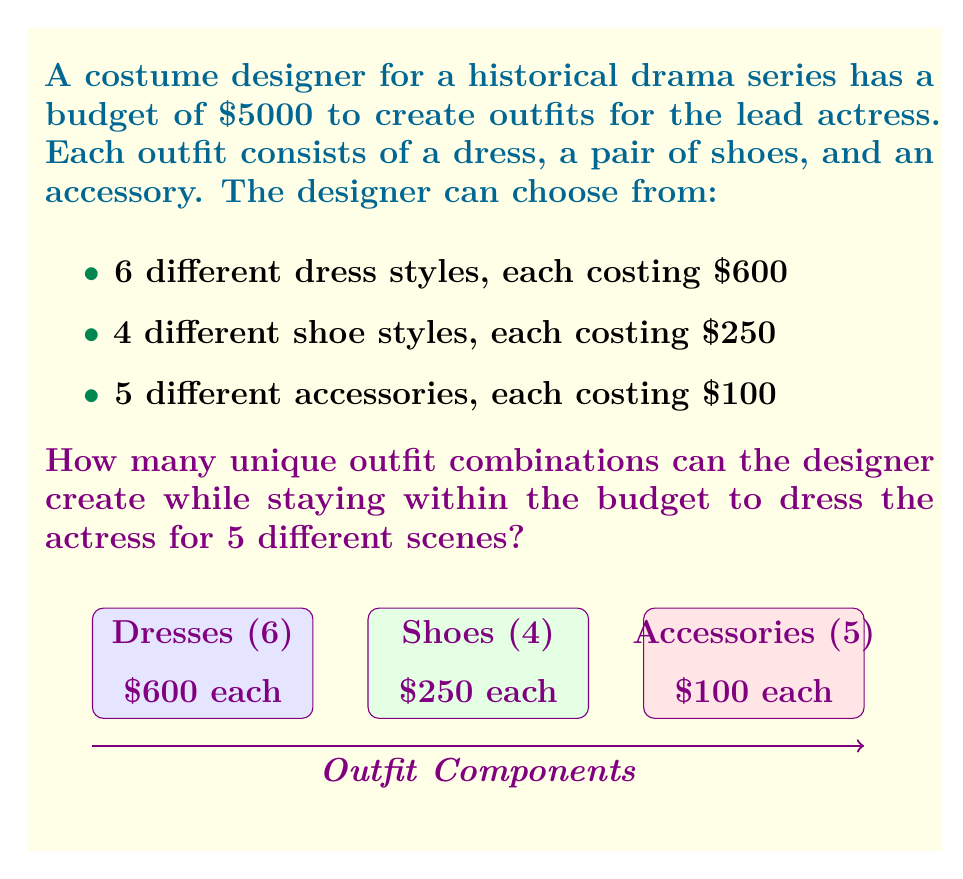Could you help me with this problem? Let's approach this step-by-step:

1) First, we need to calculate the cost of one complete outfit:
   Dress: $600
   Shoes: $250
   Accessory: $100
   Total: $600 + $250 + $100 = $950 per outfit

2) With a budget of $5000, we can create:
   $\lfloor \frac{5000}{950} \rfloor = 5$ outfits (using floor function as we can't make partial outfits)

3) Now, for each outfit, we have:
   - 6 choices for dresses
   - 4 choices for shoes
   - 5 choices for accessories

4) Using the multiplication principle of combinatorics, for each outfit, we have:
   $6 \times 4 \times 5 = 120$ possible combinations

5) However, we need to create 5 different outfits. This is a combination with repetition allowed, as the same item can be used in different outfits.

6) The formula for combinations with repetition is:
   $${n+r-1 \choose r}$$
   where $n$ is the number of types to choose from, and $r$ is the number of selections.

7) In our case:
   $n = 120$ (possible combinations for each outfit)
   $r = 5$ (number of outfits to create)

8) Plugging into the formula:
   $${120+5-1 \choose 5} = {124 \choose 5}$$

9) Calculate:
   $${124 \choose 5} = \frac{124!}{5!(124-5)!} = \frac{124!}{5!119!} = 225,150,024$$

Therefore, the designer can create 225,150,024 unique combinations of 5 outfits within the given budget.
Answer: 225,150,024 